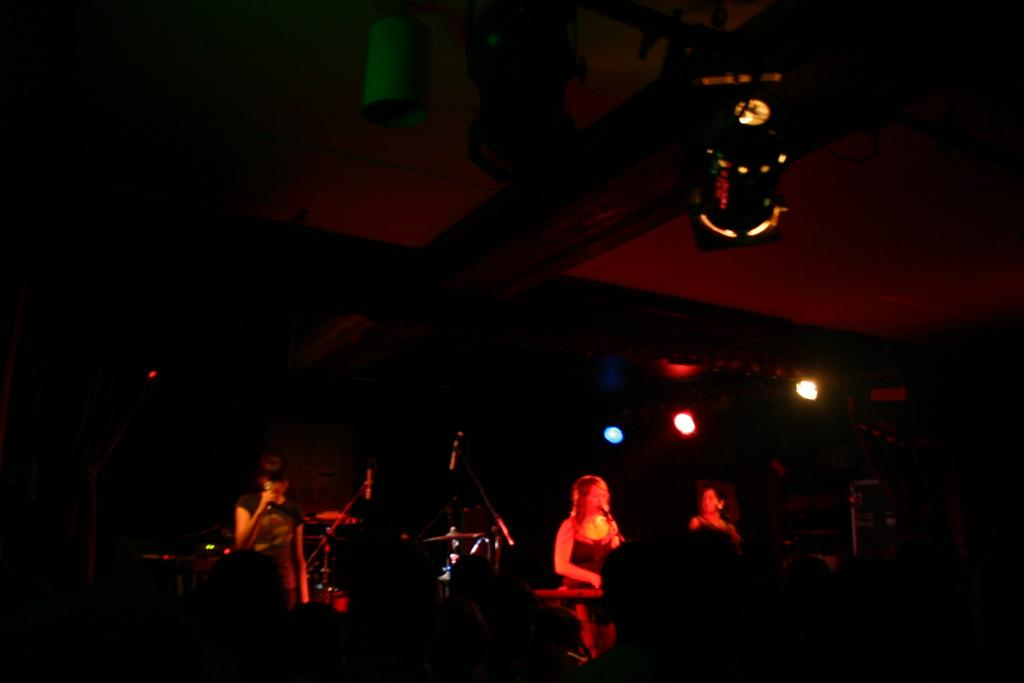How many persons are visible in the image? There are persons in the image, but the exact number is not specified. Where are the persons located in the image? The persons are on the bottom of the image. What are the persons in the background of the image holding? The persons in the background of the image are holding mics. What can be seen on the ceiling in the image? There are lights on the ceiling in the image. What type of party is happening in the image? There is no indication of a party in the image; it only shows persons on the bottom and persons holding mics in the background. What causes the thing to burst in the image? There is no thing that bursts in the image; it only features persons, mics, and lights on the ceiling. 